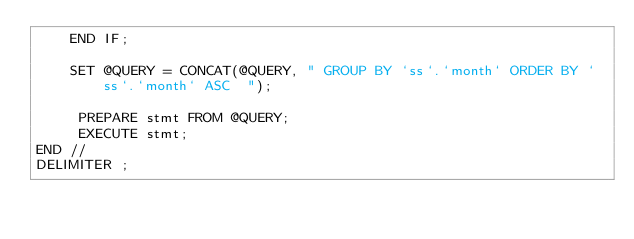<code> <loc_0><loc_0><loc_500><loc_500><_SQL_>    END IF;

    SET @QUERY = CONCAT(@QUERY, " GROUP BY `ss`.`month` ORDER BY `ss`.`month` ASC  ");

     PREPARE stmt FROM @QUERY;
     EXECUTE stmt;
END //
DELIMITER ;
</code> 